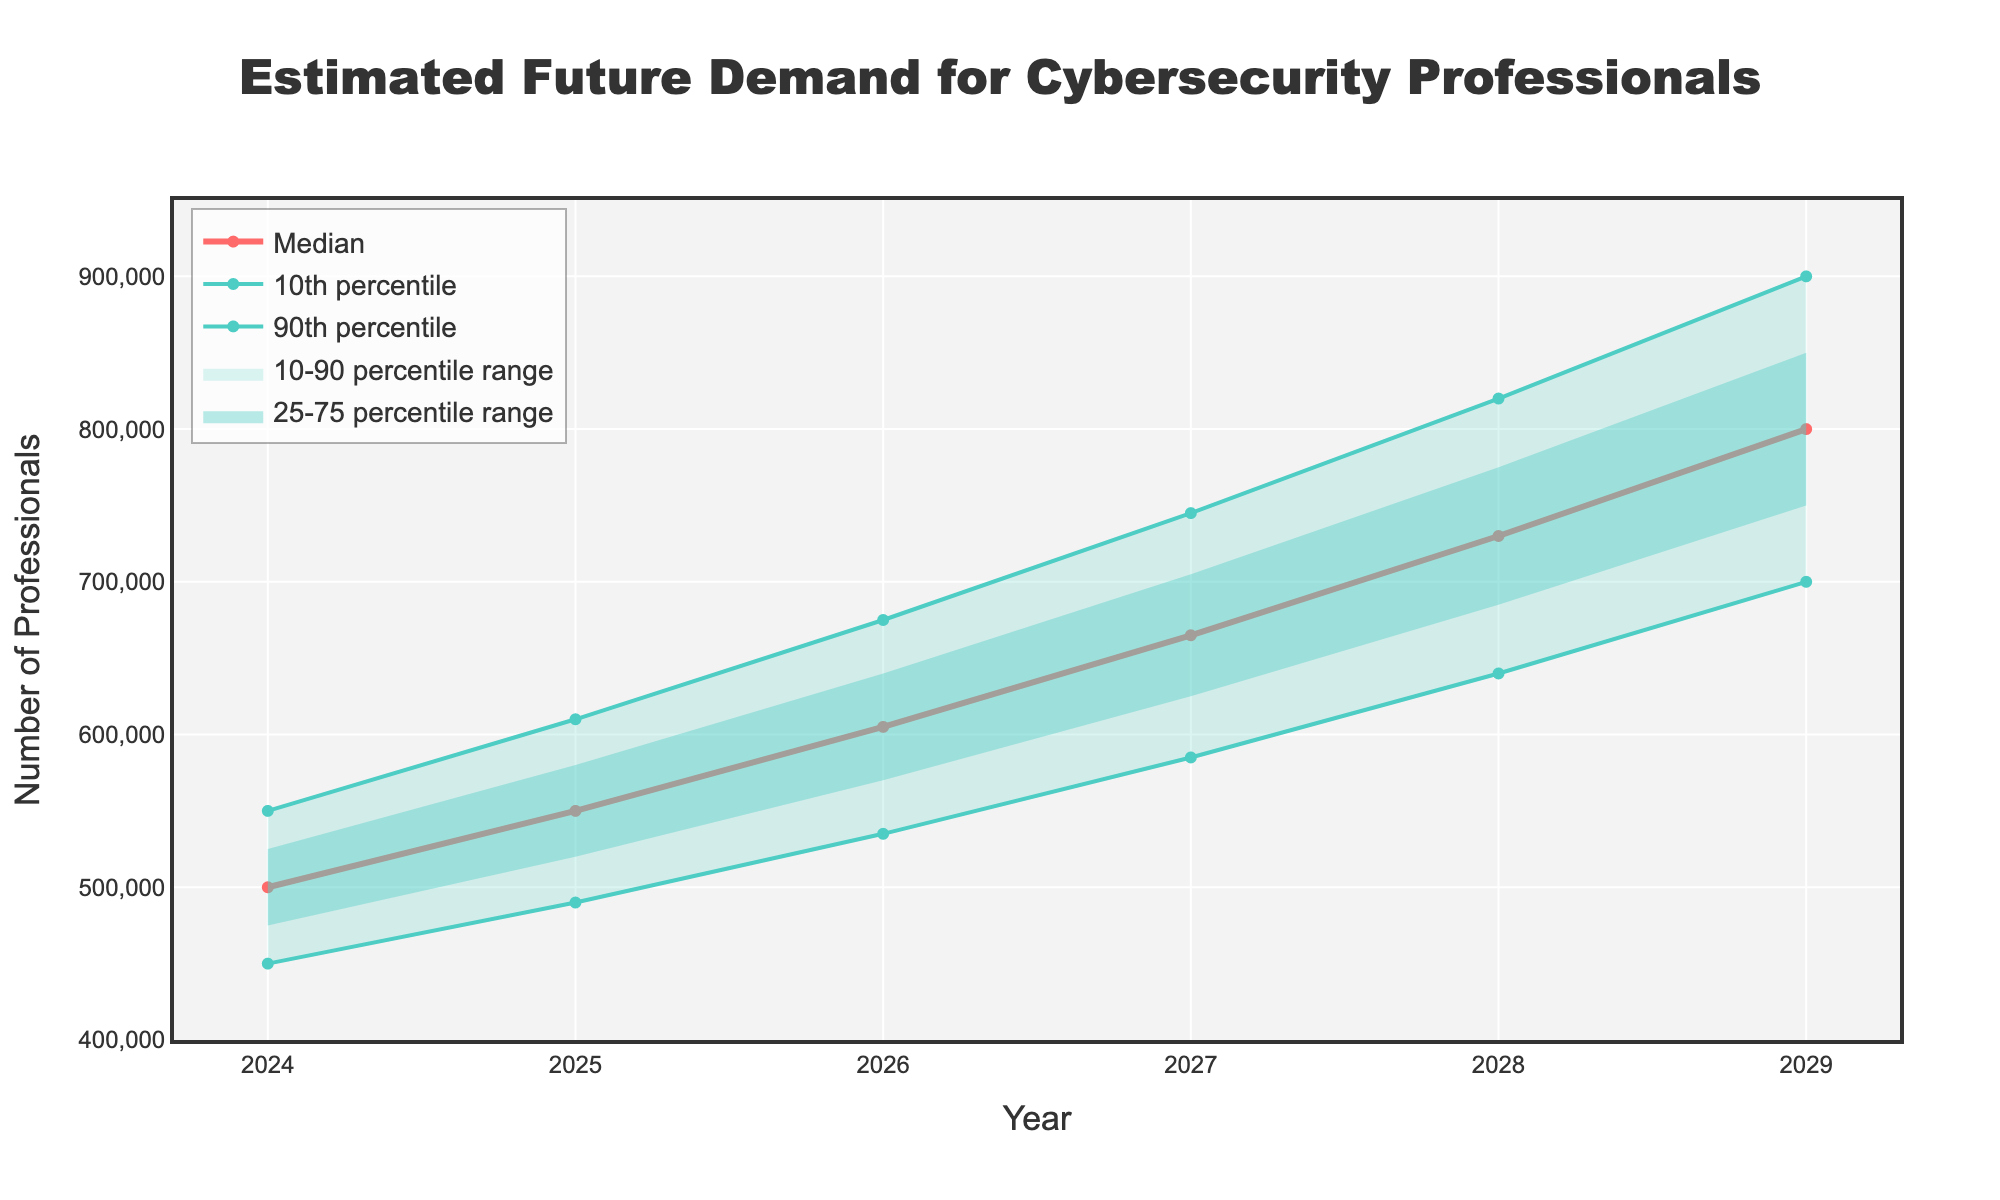What is the title of the graph? The title of the graph is usually found at the top of the figure and summarizes the subject of the plot. In this case, the title is related to the demand for cybersecurity professionals.
Answer: Estimated Future Demand for Cybersecurity Professionals What does the y-axis represent? The y-axis label indicates what the vertical axis measures. Here, it describes the number of professionals.
Answer: Number of Professionals What is the median demand for cybersecurity professionals in the year 2026? Locate the year 2026 on the x-axis and find the corresponding Median value on the plot, which indicates the estimated median number of professionals for that year.
Answer: 605,000 How does the 10th percentile value for 2028 compare to the 90th percentile value for 2029? For this comparison, locate the 10th percentile value for 2028 and the 90th percentile value for 2029 on the plot and compare them. The 10th percentile value for 2028 is 640,000, and the 90th percentile value for 2029 is 900,000.
Answer: 900,000 is higher than 640,000 What is the range of estimated demand (from 10th to 90th percentile) for the year 2025? The range is defined by the difference between the 90th and the 10th percentile values for 2025. Look at the corresponding values on the y-axis for the year 2025. The 90th percentile is 610,000 and the 10th percentile is 490,000. So, the range is 610,000 - 490,000.
Answer: 120,000 How much does the median value increase from 2024 to 2029? To find the increase, take the median value for 2029 and subtract the median value for 2024. The median in 2029 is 800,000 and in 2024 is 500,000. The increase is 800,000 - 500,000.
Answer: 300,000 What can you infer from the widening of the 10-90 percentile range over the years? The 10-90 percentile range represents the uncertainty in the estimates. If the range is widening over the years, it indicates increasing uncertainty about future demand. This is visible as the shaded area between 10 percent and 90 percent gets wider from 2024 to 2029.
Answer: Increasing uncertainty 